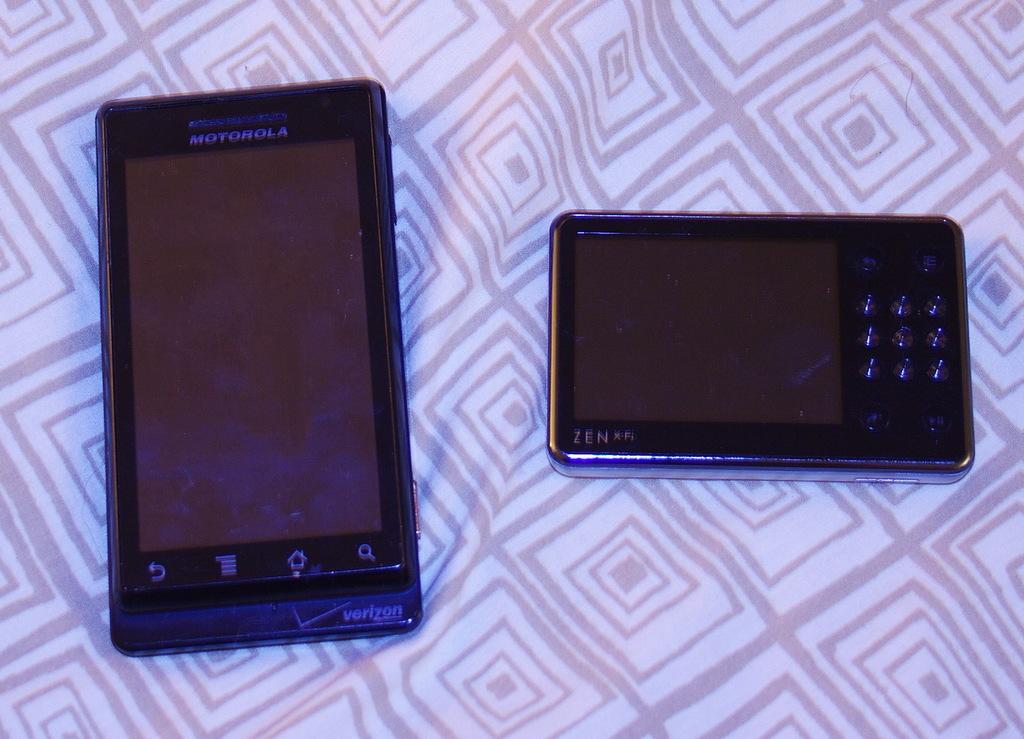What brand of phone is on the left?
Offer a terse response. Motorola. What is the three letter brand on the device on the right?
Offer a very short reply. Zen. 